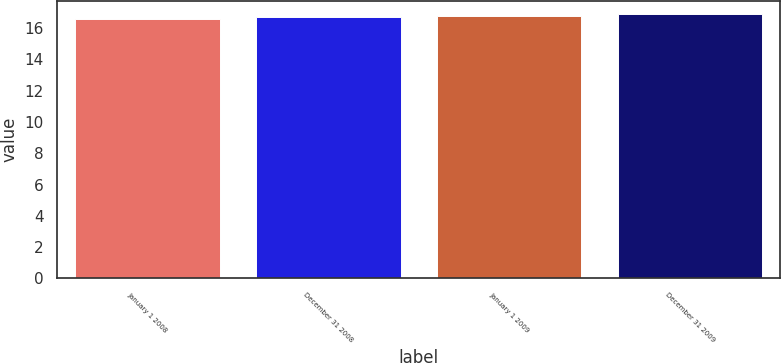Convert chart to OTSL. <chart><loc_0><loc_0><loc_500><loc_500><bar_chart><fcel>January 1 2008<fcel>December 31 2008<fcel>January 1 2009<fcel>December 31 2009<nl><fcel>16.6<fcel>16.7<fcel>16.8<fcel>16.9<nl></chart> 